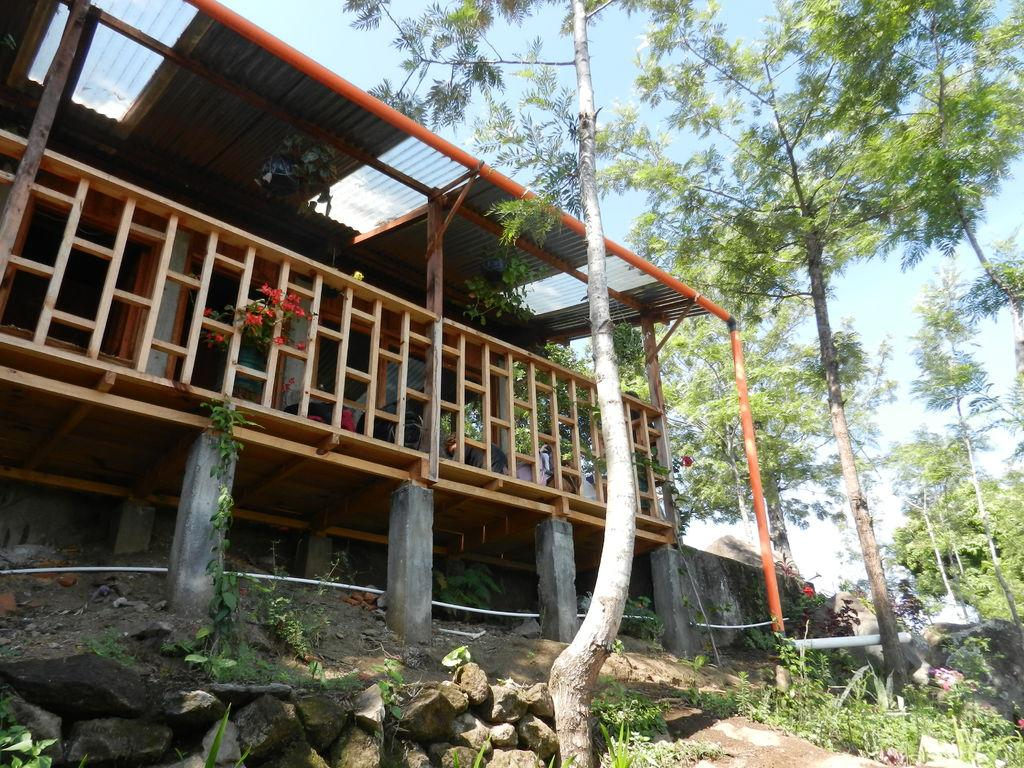What type of structure is visible in the image? There is a house in the image. Can you describe the house's features? The house has a roof, doors, windows, and pillars. What else can be seen in the image besides the house? There is a group of trees, stones, and a plant with flowers in the image. What is visible in the background of the image? The sky is visible in the image, and it looks cloudy. How many rabbits are sitting on the roof of the house in the image? There are no rabbits present in the image, so it is not possible to determine how many might be sitting on the roof. What is the title of the image? The provided facts do not include any information about a title for the image. 